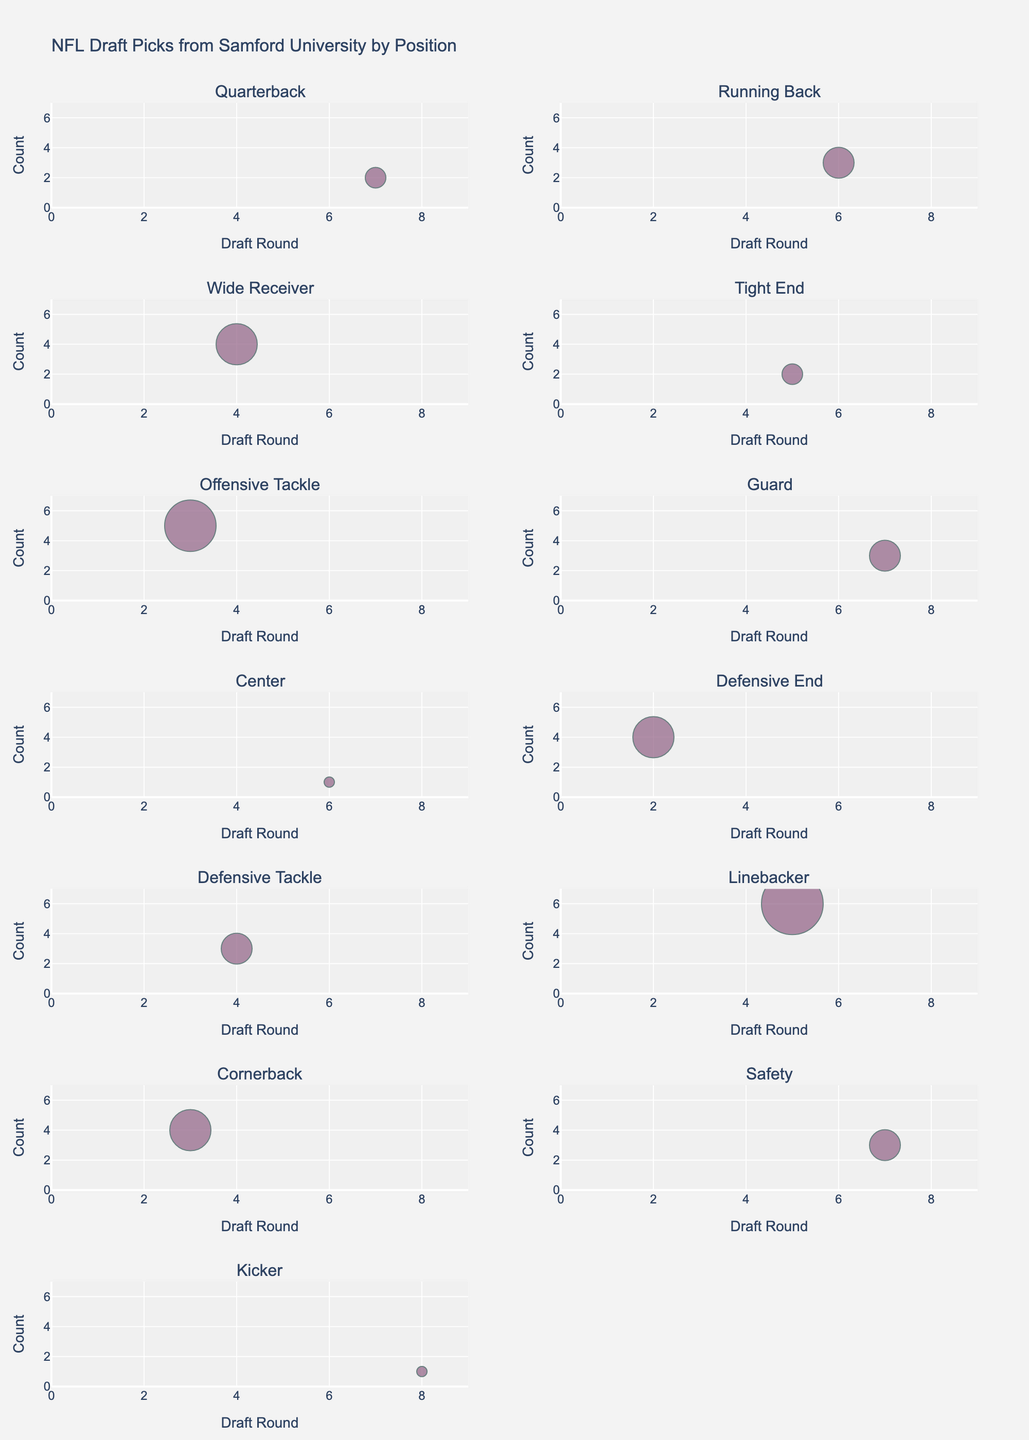What is the title of the figure? The title is always located at the top of the figure. In this case, it states the purpose of the plot.
Answer: NFL Draft Picks from Samford University by Position Which position has the most selected players in any single draft round? By looking at the bubble size, the largest bubble indicates the highest count of selected players. The largest bubble corresponds to the Linebacker position in Round 5.
Answer: Linebacker How many quarterbacks were drafted in Round 7? Identify the Quarterback subplot and look at the bubble positioned above Round 7. The bubble size reveals the count.
Answer: 2 In which draft round were the most Defensive Ends selected? Look at the Defensive End subplot for the highest bubble on the x-axis. The largest bubble is positioned above Round 2.
Answer: Round 2 Which position has players drafted in the most recent year, and what year was this? Examine the "Years" hover text for each subplot. The Linebacker subplot shows the most recent year with drafting in 2022.
Answer: Linebacker, 2022 What is the combined number of players drafted in Round 6 for any position? Sum the counts for any bubbles in Round 6 across all subplots. Running Back (3) and Center (1) are the positions in Round 6.
Answer: 4 Compare the draft rounds of the Offensive Tackle and Cornerback positions. Which position had selections in an earlier round? Check each subplot's lowest Round value. The Defensive Tackle has selections starting Round 2, while Cornerback starts at Round 3.
Answer: Defensive End Which position has the least number of draft picks overall? Look for the smallest bubbles across all subplots. The Kicker position has a single small bubble in Round 8.
Answer: Kicker What is the sum of draft counts for positions identified in Round 4? Identify the positions with bubbles in Round 4 and sum their counts. Wide Receiver (4) and Defensive Tackle (3) are in Round 4.
Answer: 7 Which position has bubbles appearing in odd-numbered draft rounds only? Look for subplots with bubbles exclusively in odd-numbered columns. The Tight End position has picks only in Rounds 5 and 7.
Answer: Tight End 